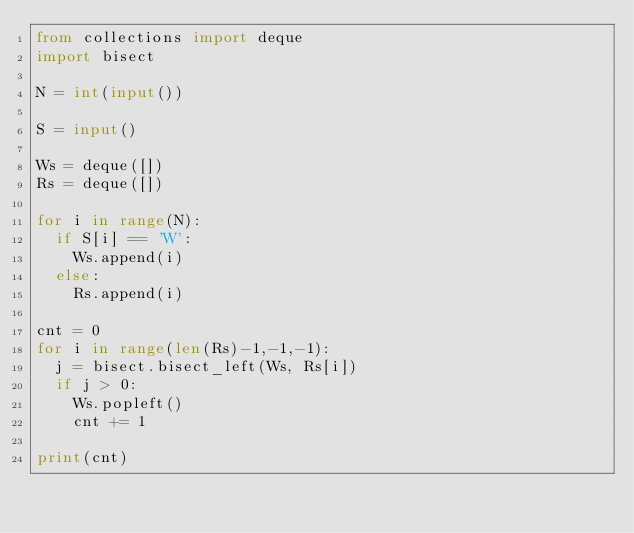Convert code to text. <code><loc_0><loc_0><loc_500><loc_500><_Python_>from collections import deque
import bisect

N = int(input())

S = input()

Ws = deque([])
Rs = deque([])

for i in range(N):
  if S[i] == 'W':
    Ws.append(i)
  else:
    Rs.append(i)
    
cnt = 0
for i in range(len(Rs)-1,-1,-1):
  j = bisect.bisect_left(Ws, Rs[i])
  if j > 0:
    Ws.popleft()
    cnt += 1
    
print(cnt)</code> 